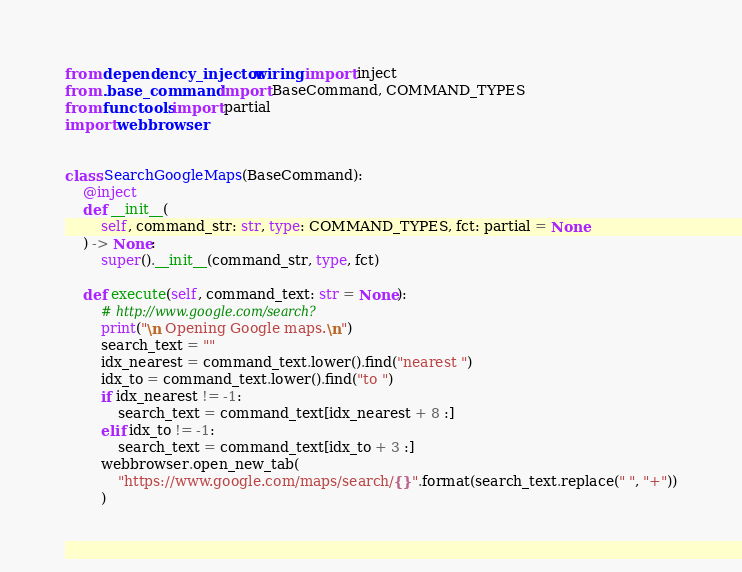Convert code to text. <code><loc_0><loc_0><loc_500><loc_500><_Python_>from dependency_injector.wiring import inject
from .base_command import BaseCommand, COMMAND_TYPES
from functools import partial
import webbrowser


class SearchGoogleMaps(BaseCommand):
    @inject
    def __init__(
        self, command_str: str, type: COMMAND_TYPES, fct: partial = None
    ) -> None:
        super().__init__(command_str, type, fct)

    def execute(self, command_text: str = None):
        # http://www.google.com/search?
        print("\n Opening Google maps.\n")
        search_text = ""
        idx_nearest = command_text.lower().find("nearest ")
        idx_to = command_text.lower().find("to ")
        if idx_nearest != -1:
            search_text = command_text[idx_nearest + 8 :]
        elif idx_to != -1:
            search_text = command_text[idx_to + 3 :]
        webbrowser.open_new_tab(
            "https://www.google.com/maps/search/{}".format(search_text.replace(" ", "+"))
        )
</code> 